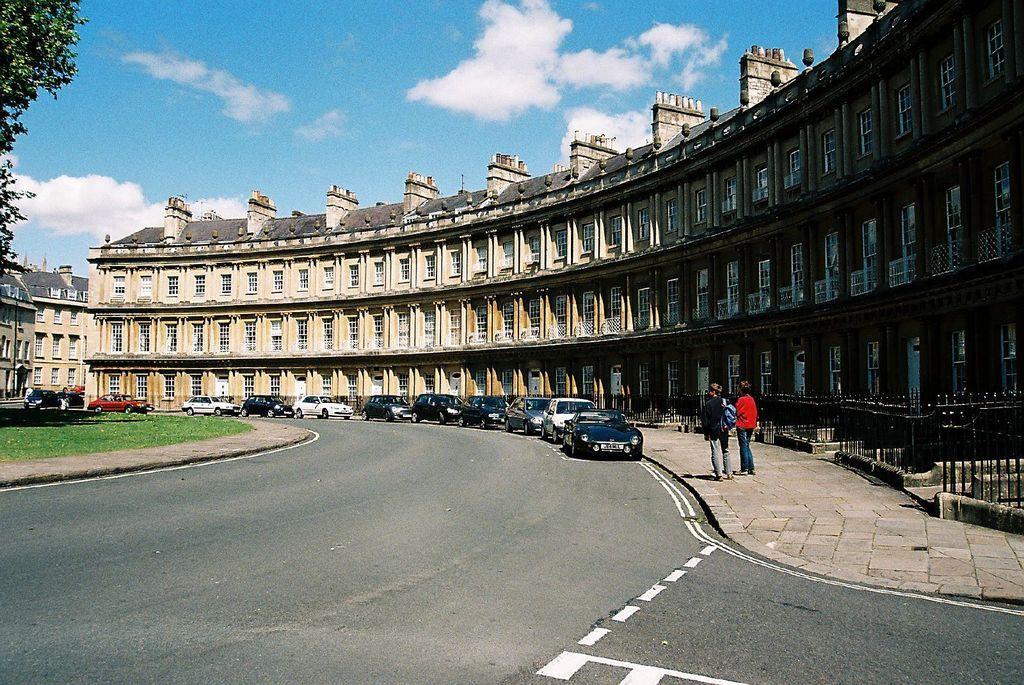Can you describe this image briefly? This image is clicked on the road. In the front, there are many cars which are parked on the road in a line. And we can see a big building along with windows. At the top, there are clouds in the sky. On the left, there is a tree. At the bottom, there is grass. 